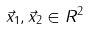<formula> <loc_0><loc_0><loc_500><loc_500>\vec { x } _ { 1 } , \vec { x } _ { 2 } \in R ^ { 2 }</formula> 